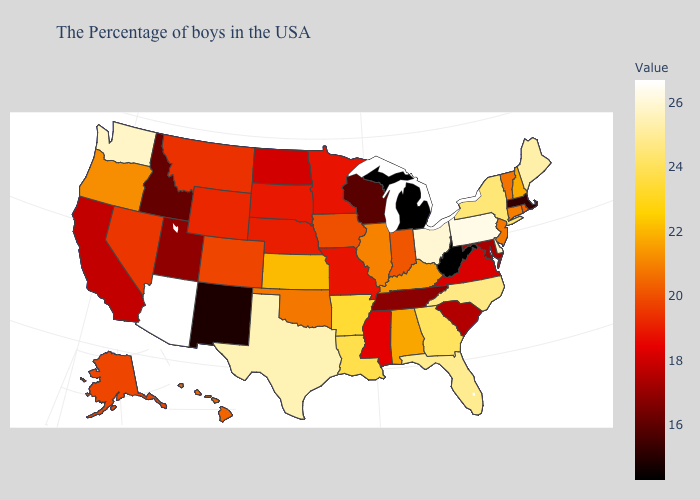Does New Jersey have the highest value in the USA?
Concise answer only. No. Among the states that border Massachusetts , which have the lowest value?
Short answer required. Rhode Island. Among the states that border Wyoming , which have the highest value?
Keep it brief. Colorado. Among the states that border South Carolina , which have the highest value?
Be succinct. North Carolina. 